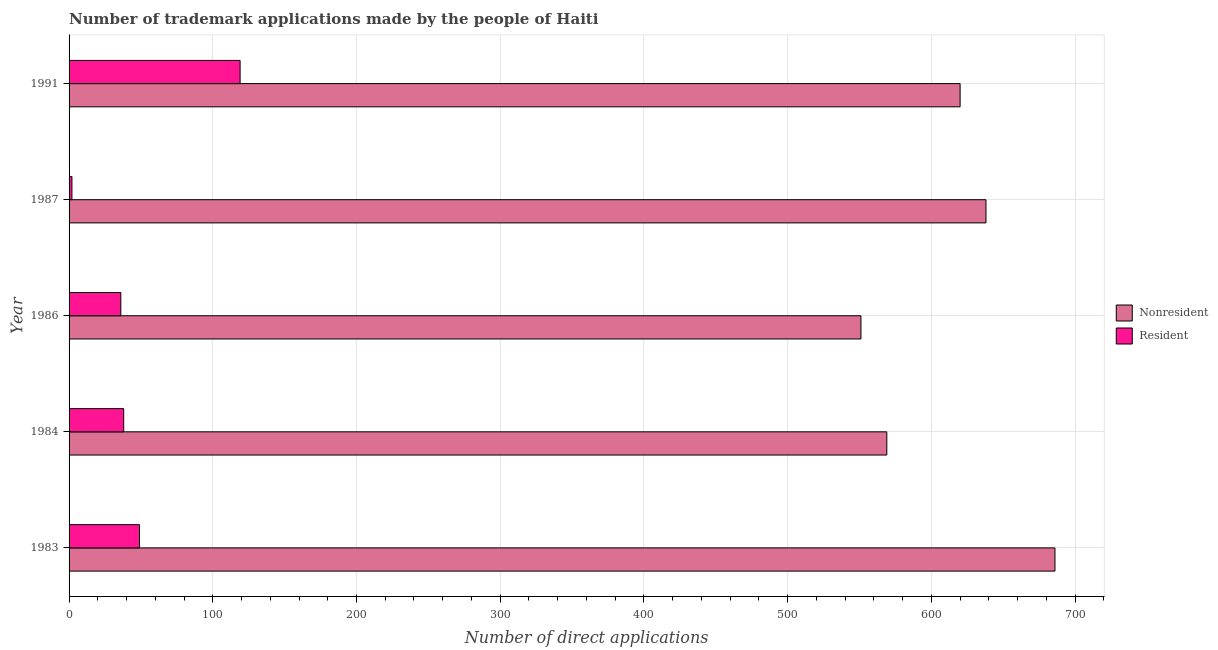How many different coloured bars are there?
Make the answer very short. 2. How many groups of bars are there?
Your answer should be very brief. 5. Are the number of bars per tick equal to the number of legend labels?
Offer a terse response. Yes. Are the number of bars on each tick of the Y-axis equal?
Provide a short and direct response. Yes. How many bars are there on the 3rd tick from the top?
Offer a terse response. 2. In how many cases, is the number of bars for a given year not equal to the number of legend labels?
Your answer should be compact. 0. What is the number of trademark applications made by non residents in 1984?
Keep it short and to the point. 569. Across all years, what is the maximum number of trademark applications made by non residents?
Offer a terse response. 686. Across all years, what is the minimum number of trademark applications made by residents?
Give a very brief answer. 2. What is the total number of trademark applications made by residents in the graph?
Give a very brief answer. 244. What is the difference between the number of trademark applications made by non residents in 1986 and that in 1991?
Your response must be concise. -69. What is the difference between the number of trademark applications made by non residents in 1983 and the number of trademark applications made by residents in 1991?
Keep it short and to the point. 567. What is the average number of trademark applications made by residents per year?
Give a very brief answer. 48.8. In the year 1987, what is the difference between the number of trademark applications made by non residents and number of trademark applications made by residents?
Offer a very short reply. 636. Is the difference between the number of trademark applications made by non residents in 1984 and 1986 greater than the difference between the number of trademark applications made by residents in 1984 and 1986?
Give a very brief answer. Yes. What is the difference between the highest and the second highest number of trademark applications made by residents?
Ensure brevity in your answer.  70. What is the difference between the highest and the lowest number of trademark applications made by residents?
Give a very brief answer. 117. In how many years, is the number of trademark applications made by residents greater than the average number of trademark applications made by residents taken over all years?
Your response must be concise. 2. Is the sum of the number of trademark applications made by residents in 1983 and 1987 greater than the maximum number of trademark applications made by non residents across all years?
Your answer should be very brief. No. What does the 1st bar from the top in 1986 represents?
Offer a very short reply. Resident. What does the 2nd bar from the bottom in 1986 represents?
Provide a succinct answer. Resident. How many bars are there?
Your response must be concise. 10. How many years are there in the graph?
Ensure brevity in your answer.  5. Does the graph contain any zero values?
Your answer should be compact. No. Where does the legend appear in the graph?
Offer a terse response. Center right. What is the title of the graph?
Keep it short and to the point. Number of trademark applications made by the people of Haiti. What is the label or title of the X-axis?
Keep it short and to the point. Number of direct applications. What is the label or title of the Y-axis?
Provide a short and direct response. Year. What is the Number of direct applications of Nonresident in 1983?
Keep it short and to the point. 686. What is the Number of direct applications in Nonresident in 1984?
Give a very brief answer. 569. What is the Number of direct applications in Resident in 1984?
Offer a very short reply. 38. What is the Number of direct applications of Nonresident in 1986?
Ensure brevity in your answer.  551. What is the Number of direct applications in Nonresident in 1987?
Give a very brief answer. 638. What is the Number of direct applications in Nonresident in 1991?
Make the answer very short. 620. What is the Number of direct applications in Resident in 1991?
Provide a succinct answer. 119. Across all years, what is the maximum Number of direct applications of Nonresident?
Your answer should be very brief. 686. Across all years, what is the maximum Number of direct applications in Resident?
Make the answer very short. 119. Across all years, what is the minimum Number of direct applications in Nonresident?
Provide a short and direct response. 551. What is the total Number of direct applications in Nonresident in the graph?
Your response must be concise. 3064. What is the total Number of direct applications of Resident in the graph?
Give a very brief answer. 244. What is the difference between the Number of direct applications of Nonresident in 1983 and that in 1984?
Your answer should be compact. 117. What is the difference between the Number of direct applications in Resident in 1983 and that in 1984?
Your answer should be very brief. 11. What is the difference between the Number of direct applications of Nonresident in 1983 and that in 1986?
Your answer should be very brief. 135. What is the difference between the Number of direct applications in Resident in 1983 and that in 1987?
Offer a very short reply. 47. What is the difference between the Number of direct applications in Nonresident in 1983 and that in 1991?
Keep it short and to the point. 66. What is the difference between the Number of direct applications in Resident in 1983 and that in 1991?
Offer a terse response. -70. What is the difference between the Number of direct applications in Resident in 1984 and that in 1986?
Ensure brevity in your answer.  2. What is the difference between the Number of direct applications of Nonresident in 1984 and that in 1987?
Give a very brief answer. -69. What is the difference between the Number of direct applications in Nonresident in 1984 and that in 1991?
Offer a terse response. -51. What is the difference between the Number of direct applications of Resident in 1984 and that in 1991?
Offer a terse response. -81. What is the difference between the Number of direct applications of Nonresident in 1986 and that in 1987?
Your answer should be compact. -87. What is the difference between the Number of direct applications of Nonresident in 1986 and that in 1991?
Provide a succinct answer. -69. What is the difference between the Number of direct applications of Resident in 1986 and that in 1991?
Your answer should be compact. -83. What is the difference between the Number of direct applications of Nonresident in 1987 and that in 1991?
Your answer should be compact. 18. What is the difference between the Number of direct applications of Resident in 1987 and that in 1991?
Your answer should be compact. -117. What is the difference between the Number of direct applications of Nonresident in 1983 and the Number of direct applications of Resident in 1984?
Your response must be concise. 648. What is the difference between the Number of direct applications of Nonresident in 1983 and the Number of direct applications of Resident in 1986?
Your answer should be compact. 650. What is the difference between the Number of direct applications of Nonresident in 1983 and the Number of direct applications of Resident in 1987?
Ensure brevity in your answer.  684. What is the difference between the Number of direct applications of Nonresident in 1983 and the Number of direct applications of Resident in 1991?
Your answer should be compact. 567. What is the difference between the Number of direct applications of Nonresident in 1984 and the Number of direct applications of Resident in 1986?
Provide a short and direct response. 533. What is the difference between the Number of direct applications in Nonresident in 1984 and the Number of direct applications in Resident in 1987?
Provide a succinct answer. 567. What is the difference between the Number of direct applications of Nonresident in 1984 and the Number of direct applications of Resident in 1991?
Your answer should be compact. 450. What is the difference between the Number of direct applications of Nonresident in 1986 and the Number of direct applications of Resident in 1987?
Offer a terse response. 549. What is the difference between the Number of direct applications of Nonresident in 1986 and the Number of direct applications of Resident in 1991?
Offer a very short reply. 432. What is the difference between the Number of direct applications of Nonresident in 1987 and the Number of direct applications of Resident in 1991?
Keep it short and to the point. 519. What is the average Number of direct applications of Nonresident per year?
Offer a terse response. 612.8. What is the average Number of direct applications in Resident per year?
Give a very brief answer. 48.8. In the year 1983, what is the difference between the Number of direct applications in Nonresident and Number of direct applications in Resident?
Your response must be concise. 637. In the year 1984, what is the difference between the Number of direct applications in Nonresident and Number of direct applications in Resident?
Provide a short and direct response. 531. In the year 1986, what is the difference between the Number of direct applications in Nonresident and Number of direct applications in Resident?
Ensure brevity in your answer.  515. In the year 1987, what is the difference between the Number of direct applications of Nonresident and Number of direct applications of Resident?
Provide a short and direct response. 636. In the year 1991, what is the difference between the Number of direct applications in Nonresident and Number of direct applications in Resident?
Your response must be concise. 501. What is the ratio of the Number of direct applications in Nonresident in 1983 to that in 1984?
Provide a succinct answer. 1.21. What is the ratio of the Number of direct applications in Resident in 1983 to that in 1984?
Keep it short and to the point. 1.29. What is the ratio of the Number of direct applications in Nonresident in 1983 to that in 1986?
Your answer should be compact. 1.25. What is the ratio of the Number of direct applications in Resident in 1983 to that in 1986?
Provide a short and direct response. 1.36. What is the ratio of the Number of direct applications in Nonresident in 1983 to that in 1987?
Give a very brief answer. 1.08. What is the ratio of the Number of direct applications of Resident in 1983 to that in 1987?
Ensure brevity in your answer.  24.5. What is the ratio of the Number of direct applications of Nonresident in 1983 to that in 1991?
Ensure brevity in your answer.  1.11. What is the ratio of the Number of direct applications of Resident in 1983 to that in 1991?
Keep it short and to the point. 0.41. What is the ratio of the Number of direct applications in Nonresident in 1984 to that in 1986?
Your answer should be very brief. 1.03. What is the ratio of the Number of direct applications of Resident in 1984 to that in 1986?
Offer a very short reply. 1.06. What is the ratio of the Number of direct applications of Nonresident in 1984 to that in 1987?
Provide a succinct answer. 0.89. What is the ratio of the Number of direct applications in Nonresident in 1984 to that in 1991?
Ensure brevity in your answer.  0.92. What is the ratio of the Number of direct applications of Resident in 1984 to that in 1991?
Your answer should be very brief. 0.32. What is the ratio of the Number of direct applications of Nonresident in 1986 to that in 1987?
Make the answer very short. 0.86. What is the ratio of the Number of direct applications in Resident in 1986 to that in 1987?
Provide a succinct answer. 18. What is the ratio of the Number of direct applications of Nonresident in 1986 to that in 1991?
Your answer should be very brief. 0.89. What is the ratio of the Number of direct applications in Resident in 1986 to that in 1991?
Provide a short and direct response. 0.3. What is the ratio of the Number of direct applications of Resident in 1987 to that in 1991?
Your answer should be very brief. 0.02. What is the difference between the highest and the second highest Number of direct applications in Nonresident?
Provide a short and direct response. 48. What is the difference between the highest and the second highest Number of direct applications in Resident?
Provide a short and direct response. 70. What is the difference between the highest and the lowest Number of direct applications of Nonresident?
Keep it short and to the point. 135. What is the difference between the highest and the lowest Number of direct applications in Resident?
Make the answer very short. 117. 